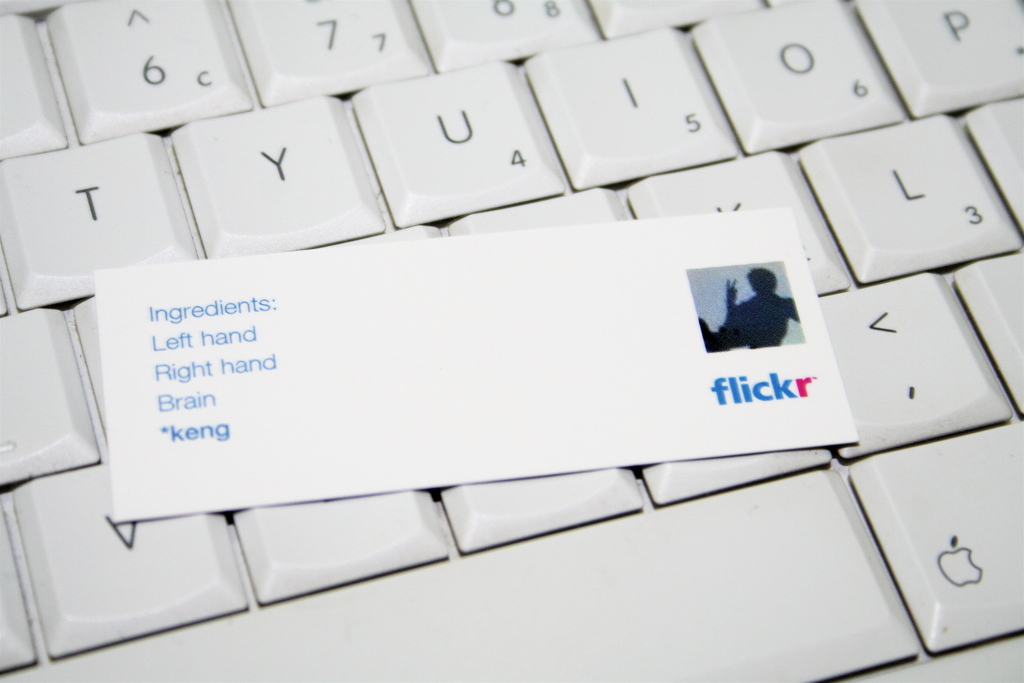Explain the visual content of the image in great detail. The image displays a close-up of a white computer keyboard. Resting on the keys is a small white business card that reads ‘Ingredients: Left hand, Right hand, Brain, *keng,’ with a blue flickr logo at the bottom right corner. The text and the logo are in blue, matching the visual theme. This setting implies a workspace dedicated to creative endeavors, where manual skills (represented by 'Left hand' and 'Right hand') and mental effort ('Brain') are essential components. The card might suggest a playful or conceptual representation of personal assets or skills required for creativity in digital environments, possibly linked to the user's activities on Flickr or similar platforms. The term '*keng' remains ambiguous, possibly a signature or a cryptic addition to the 'recipe' of creativity. 